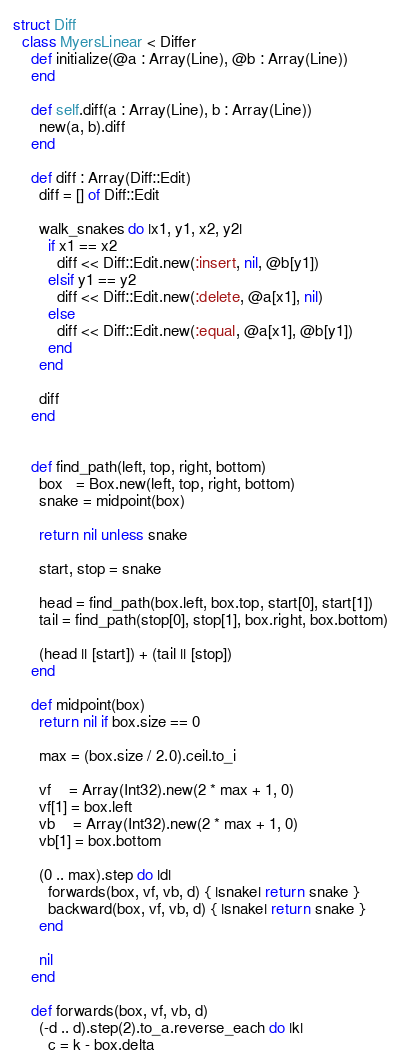<code> <loc_0><loc_0><loc_500><loc_500><_Crystal_>struct Diff
  class MyersLinear < Differ
    def initialize(@a : Array(Line), @b : Array(Line))
    end

    def self.diff(a : Array(Line), b : Array(Line))
      new(a, b).diff
    end

    def diff : Array(Diff::Edit)
      diff = [] of Diff::Edit

      walk_snakes do |x1, y1, x2, y2|
        if x1 == x2
          diff << Diff::Edit.new(:insert, nil, @b[y1])
        elsif y1 == y2
          diff << Diff::Edit.new(:delete, @a[x1], nil)
        else
          diff << Diff::Edit.new(:equal, @a[x1], @b[y1])
        end
      end

      diff
    end


    def find_path(left, top, right, bottom)
      box   = Box.new(left, top, right, bottom)
      snake = midpoint(box)

      return nil unless snake

      start, stop = snake

      head = find_path(box.left, box.top, start[0], start[1])
      tail = find_path(stop[0], stop[1], box.right, box.bottom)

      (head || [start]) + (tail || [stop])
    end

    def midpoint(box)
      return nil if box.size == 0

      max = (box.size / 2.0).ceil.to_i

      vf    = Array(Int32).new(2 * max + 1, 0)
      vf[1] = box.left
      vb    = Array(Int32).new(2 * max + 1, 0)
      vb[1] = box.bottom

      (0 .. max).step do |d|
        forwards(box, vf, vb, d) { |snake| return snake }
        backward(box, vf, vb, d) { |snake| return snake }
      end

      nil
    end

    def forwards(box, vf, vb, d)
      (-d .. d).step(2).to_a.reverse_each do |k|
        c = k - box.delta
</code> 